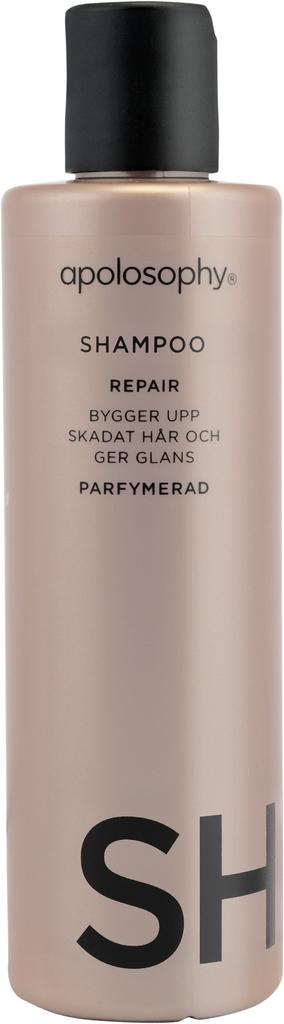Provide a one-sentence caption for the provided image. Apolosophy by SH hair repair shampoo in beige bottle. 